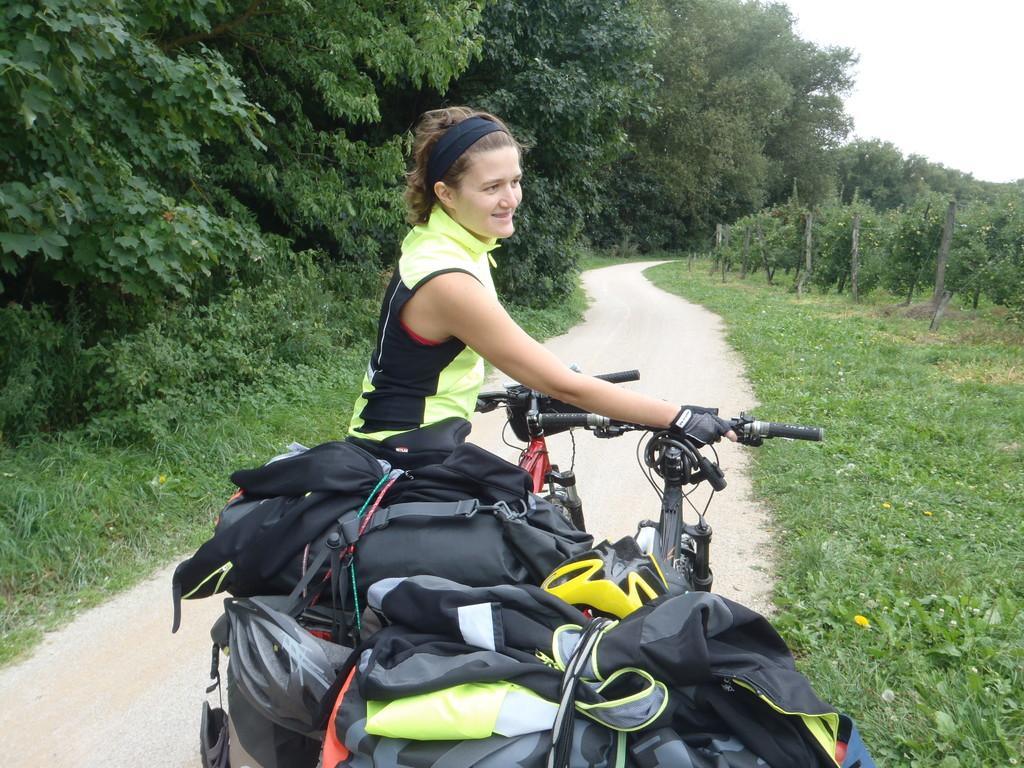Could you give a brief overview of what you see in this image? The picture is taken outside of the city. In the image there is a woman holding a bicycle, on bicycle we can see some bags. On right side of the image there are some trees with green leaves. On left side also we can see some leaves with green leaves, at bottom on right side we can see some grass. In middle there is a wide road and sky is on top. 